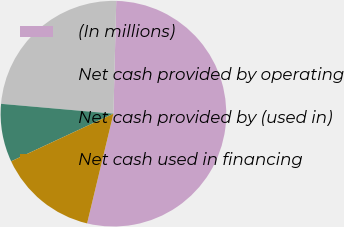<chart> <loc_0><loc_0><loc_500><loc_500><pie_chart><fcel>(In millions)<fcel>Net cash provided by operating<fcel>Net cash provided by (used in)<fcel>Net cash used in financing<nl><fcel>53.35%<fcel>24.0%<fcel>8.33%<fcel>14.31%<nl></chart> 